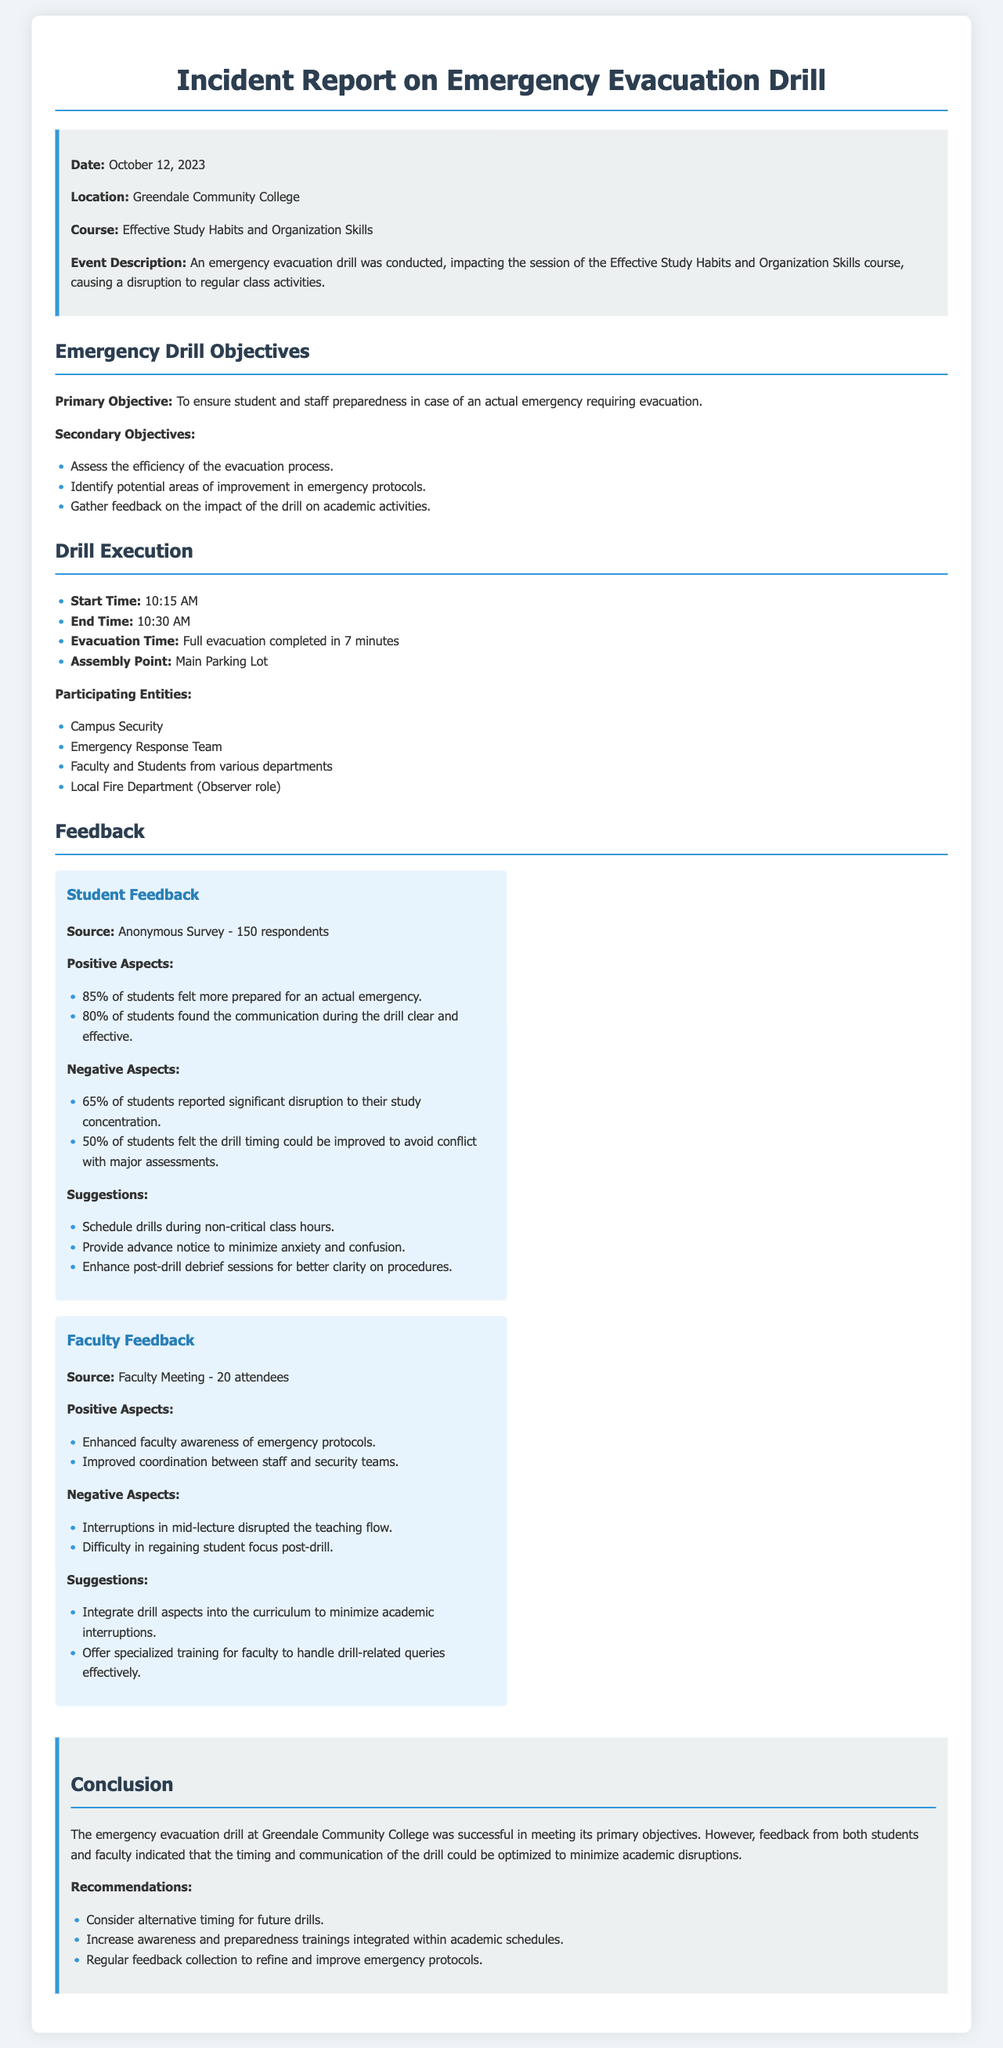what is the date of the drill? The date of the drill is stated in the introduction of the document.
Answer: October 12, 2023 what was the duration of the evacuation? This information can be found in the "Drill Execution" section as it details the time taken for the evacuation.
Answer: 7 minutes how many students responded to the feedback survey? The number of respondents is specified in the "Student Feedback" section of the document.
Answer: 150 respondents what is one suggestion from students to minimize disruption? This can be found in the suggestions listed under "Student Feedback," showing a student proposal.
Answer: Schedule drills during non-critical class hours how many faculty members attended the feedback meeting? The document specifies the number of attendees in the "Faculty Feedback" section.
Answer: 20 attendees what significant negative aspect did 65% of students report? This is discussed in the negative aspects section under "Student Feedback."
Answer: Significant disruption to their study concentration what was the primary objective of the drill? The primary objective is clearly laid out in the "Emergency Drill Objectives" section.
Answer: To ensure student and staff preparedness in case of an actual emergency requiring evacuation what was a positive feedback from faculty regarding the drill? This is detailed in the "Positive Aspects" section of the "Faculty Feedback."
Answer: Enhanced faculty awareness of emergency protocols what is one recommendation given in the conclusion? The recommendations are summarized at the end of the document in the "Conclusion" section.
Answer: Consider alternative timing for future drills 